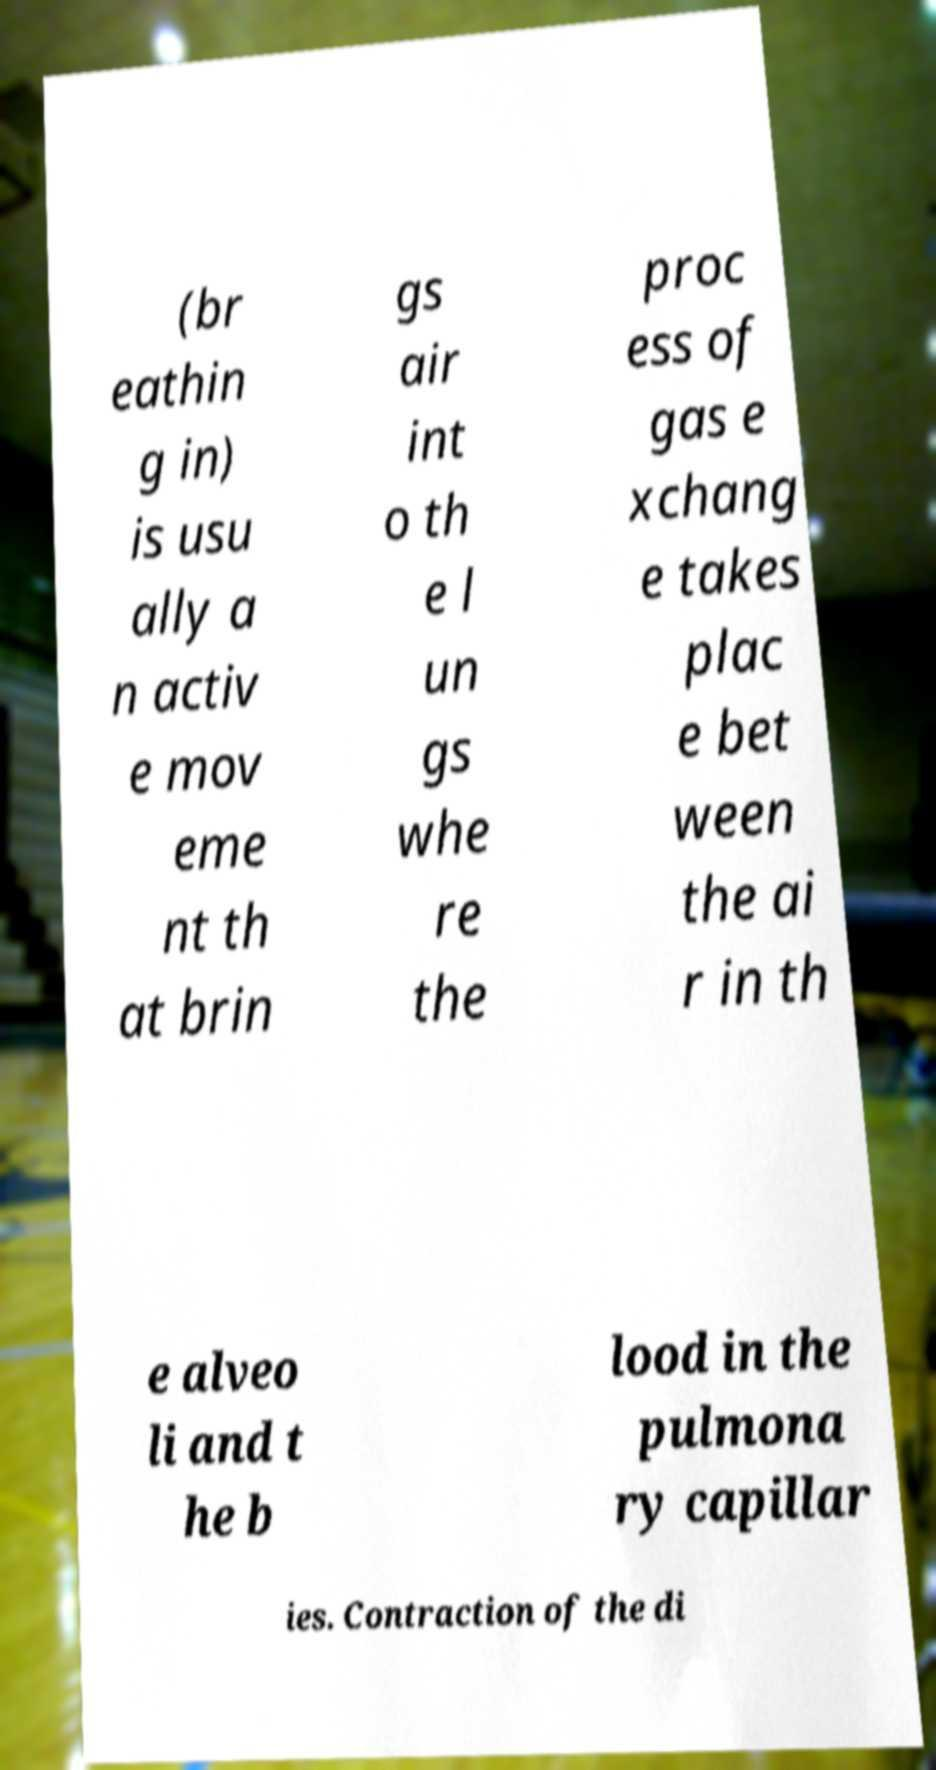Please read and relay the text visible in this image. What does it say? (br eathin g in) is usu ally a n activ e mov eme nt th at brin gs air int o th e l un gs whe re the proc ess of gas e xchang e takes plac e bet ween the ai r in th e alveo li and t he b lood in the pulmona ry capillar ies. Contraction of the di 